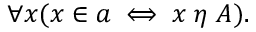Convert formula to latex. <formula><loc_0><loc_0><loc_500><loc_500>\forall x ( x \in a \iff x \, \eta \, A ) .</formula> 